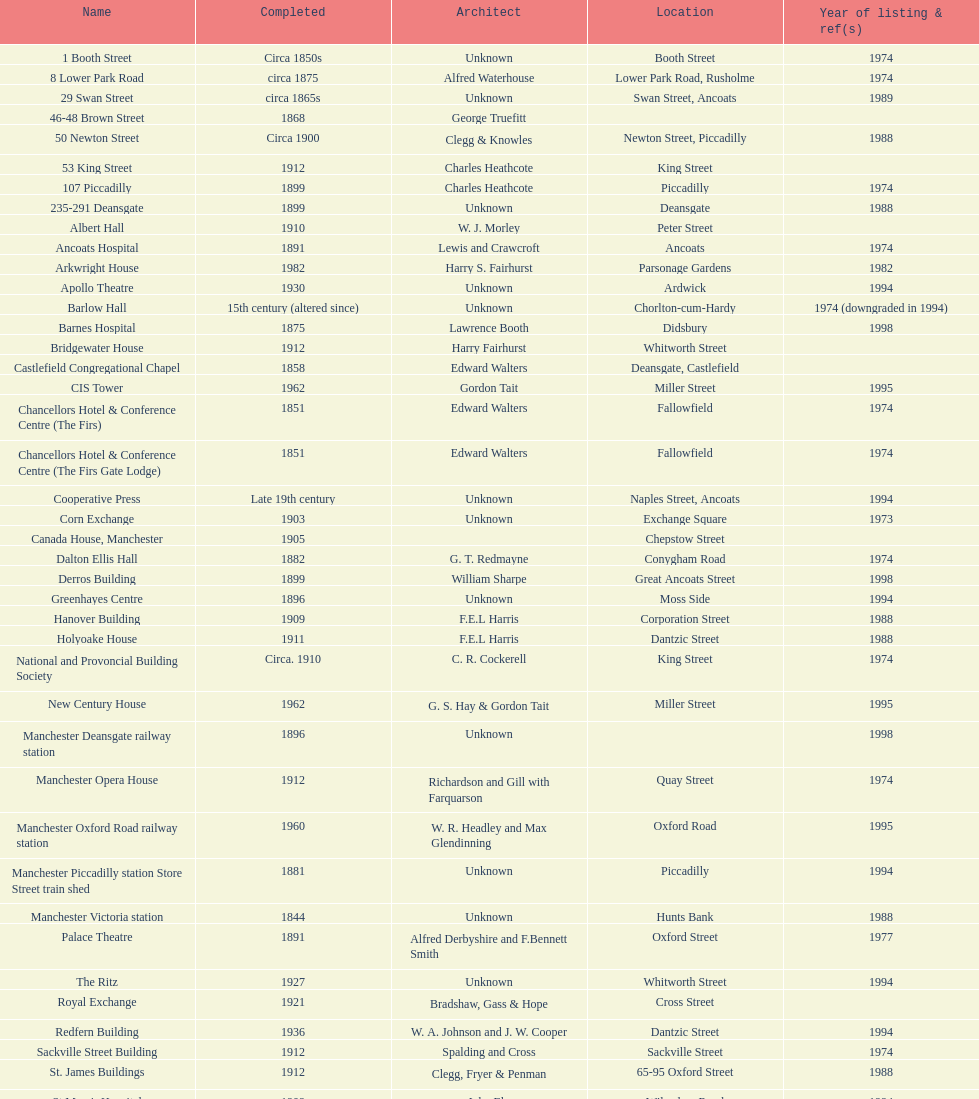What is the gap, in terms of years, between the completion of 53 king street and castlefield congregational chapel? 54 years. 